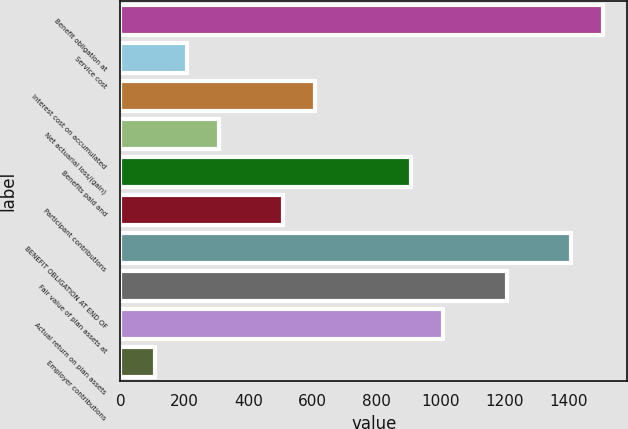<chart> <loc_0><loc_0><loc_500><loc_500><bar_chart><fcel>Benefit obligation at<fcel>Service cost<fcel>Interest cost on accumulated<fcel>Net actuarial loss/(gain)<fcel>Benefits paid and<fcel>Participant contributions<fcel>BENEFIT OBLIGATION AT END OF<fcel>Fair value of plan assets at<fcel>Actual return on plan assets<fcel>Employer contributions<nl><fcel>1507<fcel>207<fcel>607<fcel>307<fcel>907<fcel>507<fcel>1407<fcel>1207<fcel>1007<fcel>107<nl></chart> 